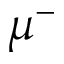Convert formula to latex. <formula><loc_0><loc_0><loc_500><loc_500>\mu ^ { - }</formula> 